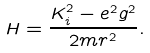Convert formula to latex. <formula><loc_0><loc_0><loc_500><loc_500>H = \frac { K _ { i } ^ { 2 } - e ^ { 2 } g ^ { 2 } } { 2 m r ^ { 2 } } .</formula> 